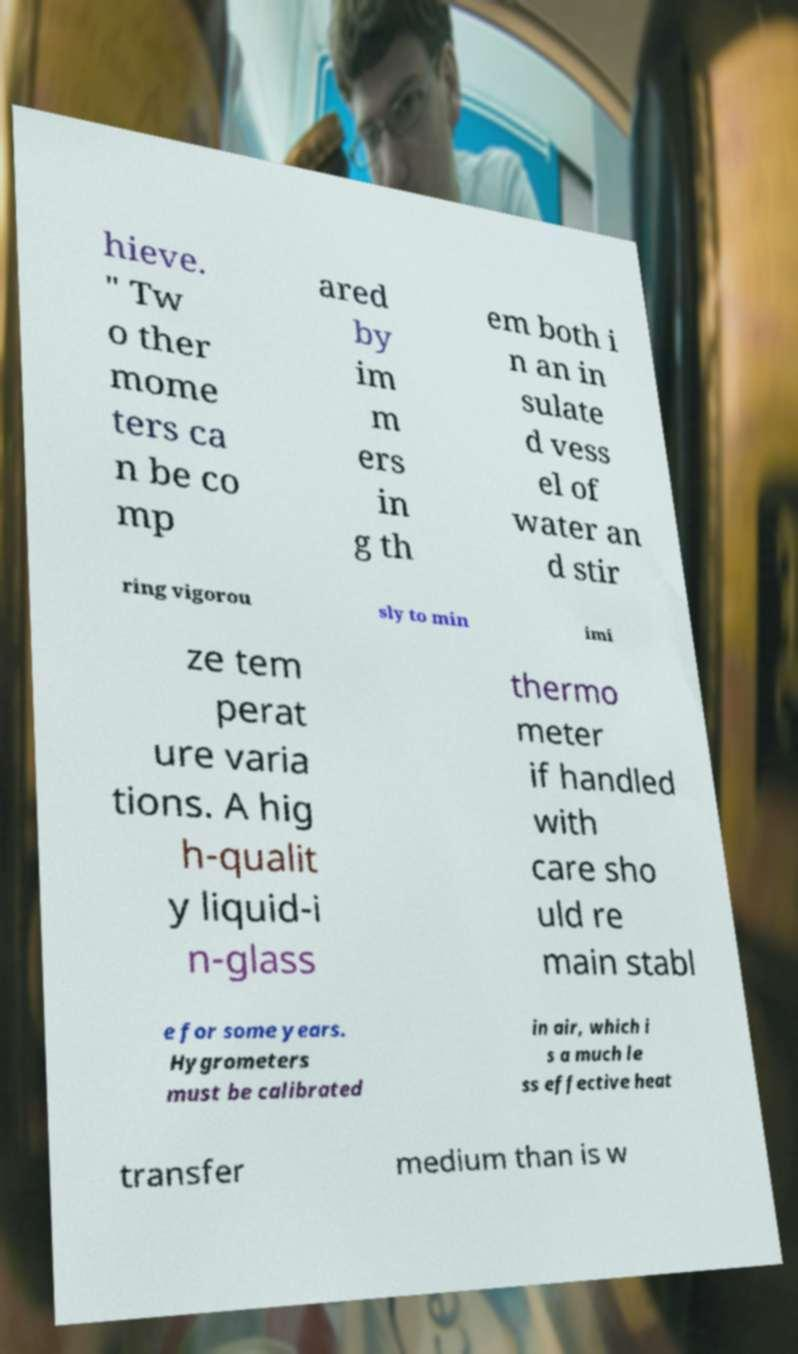Can you accurately transcribe the text from the provided image for me? hieve. " Tw o ther mome ters ca n be co mp ared by im m ers in g th em both i n an in sulate d vess el of water an d stir ring vigorou sly to min imi ze tem perat ure varia tions. A hig h-qualit y liquid-i n-glass thermo meter if handled with care sho uld re main stabl e for some years. Hygrometers must be calibrated in air, which i s a much le ss effective heat transfer medium than is w 